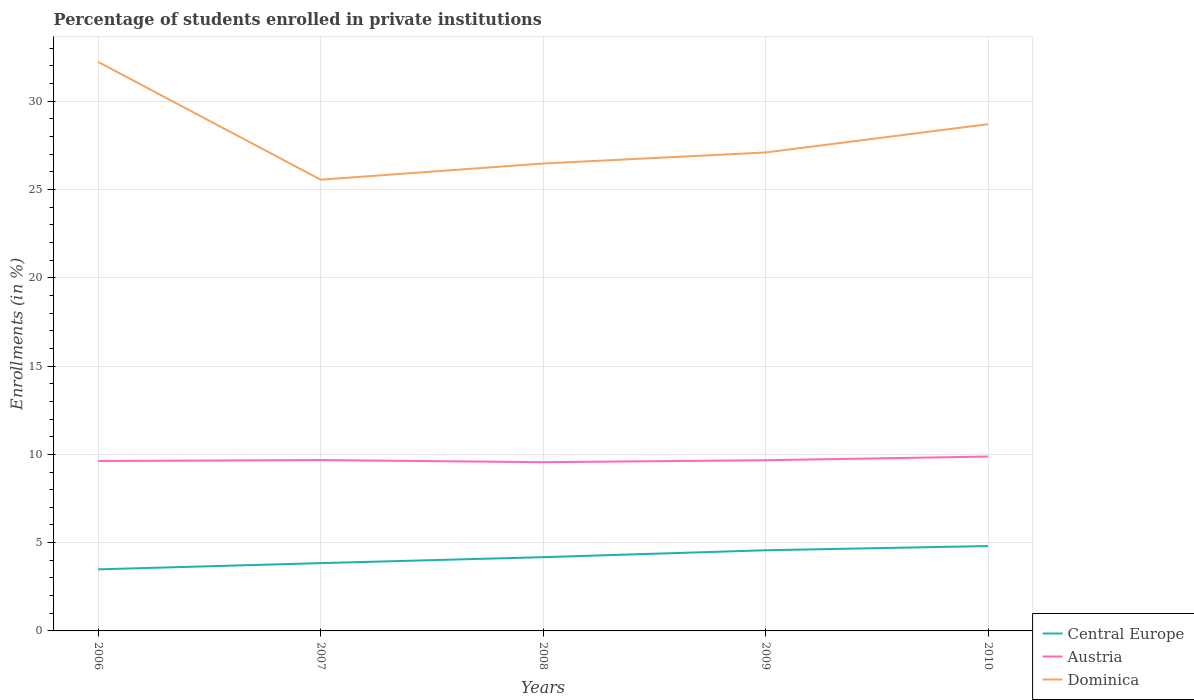How many different coloured lines are there?
Your response must be concise. 3. Across all years, what is the maximum percentage of trained teachers in Austria?
Ensure brevity in your answer.  9.56. What is the total percentage of trained teachers in Austria in the graph?
Your answer should be very brief. 0.07. What is the difference between the highest and the second highest percentage of trained teachers in Central Europe?
Your response must be concise. 1.32. What is the difference between the highest and the lowest percentage of trained teachers in Central Europe?
Your response must be concise. 3. How many lines are there?
Your answer should be very brief. 3. How many years are there in the graph?
Provide a succinct answer. 5. What is the difference between two consecutive major ticks on the Y-axis?
Offer a very short reply. 5. Are the values on the major ticks of Y-axis written in scientific E-notation?
Your answer should be compact. No. Does the graph contain any zero values?
Offer a very short reply. No. Does the graph contain grids?
Your answer should be compact. Yes. Where does the legend appear in the graph?
Provide a short and direct response. Bottom right. How many legend labels are there?
Ensure brevity in your answer.  3. How are the legend labels stacked?
Give a very brief answer. Vertical. What is the title of the graph?
Give a very brief answer. Percentage of students enrolled in private institutions. Does "Philippines" appear as one of the legend labels in the graph?
Keep it short and to the point. No. What is the label or title of the Y-axis?
Provide a short and direct response. Enrollments (in %). What is the Enrollments (in %) in Central Europe in 2006?
Offer a terse response. 3.49. What is the Enrollments (in %) of Austria in 2006?
Ensure brevity in your answer.  9.62. What is the Enrollments (in %) in Dominica in 2006?
Offer a terse response. 32.23. What is the Enrollments (in %) in Central Europe in 2007?
Give a very brief answer. 3.84. What is the Enrollments (in %) of Austria in 2007?
Offer a terse response. 9.68. What is the Enrollments (in %) in Dominica in 2007?
Offer a terse response. 25.56. What is the Enrollments (in %) in Central Europe in 2008?
Ensure brevity in your answer.  4.18. What is the Enrollments (in %) in Austria in 2008?
Your answer should be very brief. 9.56. What is the Enrollments (in %) in Dominica in 2008?
Offer a terse response. 26.47. What is the Enrollments (in %) in Central Europe in 2009?
Give a very brief answer. 4.57. What is the Enrollments (in %) of Austria in 2009?
Offer a terse response. 9.67. What is the Enrollments (in %) in Dominica in 2009?
Provide a short and direct response. 27.1. What is the Enrollments (in %) in Central Europe in 2010?
Your answer should be compact. 4.81. What is the Enrollments (in %) in Austria in 2010?
Your answer should be compact. 9.88. What is the Enrollments (in %) in Dominica in 2010?
Your answer should be very brief. 28.7. Across all years, what is the maximum Enrollments (in %) in Central Europe?
Provide a succinct answer. 4.81. Across all years, what is the maximum Enrollments (in %) in Austria?
Offer a terse response. 9.88. Across all years, what is the maximum Enrollments (in %) of Dominica?
Make the answer very short. 32.23. Across all years, what is the minimum Enrollments (in %) of Central Europe?
Offer a very short reply. 3.49. Across all years, what is the minimum Enrollments (in %) of Austria?
Your response must be concise. 9.56. Across all years, what is the minimum Enrollments (in %) in Dominica?
Your answer should be compact. 25.56. What is the total Enrollments (in %) in Central Europe in the graph?
Keep it short and to the point. 20.88. What is the total Enrollments (in %) in Austria in the graph?
Your answer should be very brief. 48.41. What is the total Enrollments (in %) of Dominica in the graph?
Offer a very short reply. 140.06. What is the difference between the Enrollments (in %) in Central Europe in 2006 and that in 2007?
Offer a terse response. -0.35. What is the difference between the Enrollments (in %) in Austria in 2006 and that in 2007?
Your answer should be very brief. -0.05. What is the difference between the Enrollments (in %) in Dominica in 2006 and that in 2007?
Provide a short and direct response. 6.67. What is the difference between the Enrollments (in %) in Central Europe in 2006 and that in 2008?
Ensure brevity in your answer.  -0.69. What is the difference between the Enrollments (in %) of Austria in 2006 and that in 2008?
Your response must be concise. 0.07. What is the difference between the Enrollments (in %) of Dominica in 2006 and that in 2008?
Your response must be concise. 5.75. What is the difference between the Enrollments (in %) of Central Europe in 2006 and that in 2009?
Provide a short and direct response. -1.08. What is the difference between the Enrollments (in %) of Austria in 2006 and that in 2009?
Your answer should be very brief. -0.04. What is the difference between the Enrollments (in %) of Dominica in 2006 and that in 2009?
Offer a terse response. 5.13. What is the difference between the Enrollments (in %) in Central Europe in 2006 and that in 2010?
Offer a very short reply. -1.32. What is the difference between the Enrollments (in %) of Austria in 2006 and that in 2010?
Give a very brief answer. -0.25. What is the difference between the Enrollments (in %) of Dominica in 2006 and that in 2010?
Your response must be concise. 3.53. What is the difference between the Enrollments (in %) of Central Europe in 2007 and that in 2008?
Provide a succinct answer. -0.34. What is the difference between the Enrollments (in %) of Austria in 2007 and that in 2008?
Provide a succinct answer. 0.12. What is the difference between the Enrollments (in %) in Dominica in 2007 and that in 2008?
Your answer should be very brief. -0.92. What is the difference between the Enrollments (in %) in Central Europe in 2007 and that in 2009?
Offer a very short reply. -0.73. What is the difference between the Enrollments (in %) in Austria in 2007 and that in 2009?
Offer a terse response. 0.01. What is the difference between the Enrollments (in %) of Dominica in 2007 and that in 2009?
Your answer should be compact. -1.54. What is the difference between the Enrollments (in %) of Central Europe in 2007 and that in 2010?
Offer a terse response. -0.97. What is the difference between the Enrollments (in %) in Austria in 2007 and that in 2010?
Keep it short and to the point. -0.2. What is the difference between the Enrollments (in %) of Dominica in 2007 and that in 2010?
Ensure brevity in your answer.  -3.14. What is the difference between the Enrollments (in %) of Central Europe in 2008 and that in 2009?
Ensure brevity in your answer.  -0.39. What is the difference between the Enrollments (in %) of Austria in 2008 and that in 2009?
Your answer should be very brief. -0.11. What is the difference between the Enrollments (in %) of Dominica in 2008 and that in 2009?
Keep it short and to the point. -0.63. What is the difference between the Enrollments (in %) in Central Europe in 2008 and that in 2010?
Offer a terse response. -0.63. What is the difference between the Enrollments (in %) of Austria in 2008 and that in 2010?
Provide a short and direct response. -0.32. What is the difference between the Enrollments (in %) of Dominica in 2008 and that in 2010?
Your answer should be very brief. -2.23. What is the difference between the Enrollments (in %) in Central Europe in 2009 and that in 2010?
Give a very brief answer. -0.24. What is the difference between the Enrollments (in %) of Austria in 2009 and that in 2010?
Keep it short and to the point. -0.21. What is the difference between the Enrollments (in %) in Dominica in 2009 and that in 2010?
Give a very brief answer. -1.6. What is the difference between the Enrollments (in %) in Central Europe in 2006 and the Enrollments (in %) in Austria in 2007?
Your answer should be very brief. -6.19. What is the difference between the Enrollments (in %) in Central Europe in 2006 and the Enrollments (in %) in Dominica in 2007?
Provide a succinct answer. -22.07. What is the difference between the Enrollments (in %) in Austria in 2006 and the Enrollments (in %) in Dominica in 2007?
Provide a short and direct response. -15.93. What is the difference between the Enrollments (in %) in Central Europe in 2006 and the Enrollments (in %) in Austria in 2008?
Provide a short and direct response. -6.07. What is the difference between the Enrollments (in %) of Central Europe in 2006 and the Enrollments (in %) of Dominica in 2008?
Keep it short and to the point. -22.99. What is the difference between the Enrollments (in %) of Austria in 2006 and the Enrollments (in %) of Dominica in 2008?
Your response must be concise. -16.85. What is the difference between the Enrollments (in %) of Central Europe in 2006 and the Enrollments (in %) of Austria in 2009?
Your answer should be very brief. -6.18. What is the difference between the Enrollments (in %) of Central Europe in 2006 and the Enrollments (in %) of Dominica in 2009?
Keep it short and to the point. -23.61. What is the difference between the Enrollments (in %) of Austria in 2006 and the Enrollments (in %) of Dominica in 2009?
Provide a succinct answer. -17.48. What is the difference between the Enrollments (in %) of Central Europe in 2006 and the Enrollments (in %) of Austria in 2010?
Your answer should be compact. -6.39. What is the difference between the Enrollments (in %) of Central Europe in 2006 and the Enrollments (in %) of Dominica in 2010?
Your answer should be very brief. -25.21. What is the difference between the Enrollments (in %) of Austria in 2006 and the Enrollments (in %) of Dominica in 2010?
Provide a succinct answer. -19.08. What is the difference between the Enrollments (in %) of Central Europe in 2007 and the Enrollments (in %) of Austria in 2008?
Make the answer very short. -5.72. What is the difference between the Enrollments (in %) in Central Europe in 2007 and the Enrollments (in %) in Dominica in 2008?
Your answer should be very brief. -22.63. What is the difference between the Enrollments (in %) in Austria in 2007 and the Enrollments (in %) in Dominica in 2008?
Keep it short and to the point. -16.8. What is the difference between the Enrollments (in %) of Central Europe in 2007 and the Enrollments (in %) of Austria in 2009?
Your response must be concise. -5.83. What is the difference between the Enrollments (in %) of Central Europe in 2007 and the Enrollments (in %) of Dominica in 2009?
Provide a succinct answer. -23.26. What is the difference between the Enrollments (in %) in Austria in 2007 and the Enrollments (in %) in Dominica in 2009?
Your response must be concise. -17.42. What is the difference between the Enrollments (in %) of Central Europe in 2007 and the Enrollments (in %) of Austria in 2010?
Offer a terse response. -6.04. What is the difference between the Enrollments (in %) of Central Europe in 2007 and the Enrollments (in %) of Dominica in 2010?
Offer a terse response. -24.86. What is the difference between the Enrollments (in %) of Austria in 2007 and the Enrollments (in %) of Dominica in 2010?
Your response must be concise. -19.02. What is the difference between the Enrollments (in %) in Central Europe in 2008 and the Enrollments (in %) in Austria in 2009?
Keep it short and to the point. -5.49. What is the difference between the Enrollments (in %) of Central Europe in 2008 and the Enrollments (in %) of Dominica in 2009?
Provide a short and direct response. -22.92. What is the difference between the Enrollments (in %) in Austria in 2008 and the Enrollments (in %) in Dominica in 2009?
Offer a terse response. -17.54. What is the difference between the Enrollments (in %) in Central Europe in 2008 and the Enrollments (in %) in Austria in 2010?
Ensure brevity in your answer.  -5.7. What is the difference between the Enrollments (in %) of Central Europe in 2008 and the Enrollments (in %) of Dominica in 2010?
Ensure brevity in your answer.  -24.52. What is the difference between the Enrollments (in %) of Austria in 2008 and the Enrollments (in %) of Dominica in 2010?
Ensure brevity in your answer.  -19.15. What is the difference between the Enrollments (in %) in Central Europe in 2009 and the Enrollments (in %) in Austria in 2010?
Provide a short and direct response. -5.31. What is the difference between the Enrollments (in %) in Central Europe in 2009 and the Enrollments (in %) in Dominica in 2010?
Your response must be concise. -24.13. What is the difference between the Enrollments (in %) of Austria in 2009 and the Enrollments (in %) of Dominica in 2010?
Offer a very short reply. -19.03. What is the average Enrollments (in %) in Central Europe per year?
Give a very brief answer. 4.18. What is the average Enrollments (in %) in Austria per year?
Provide a succinct answer. 9.68. What is the average Enrollments (in %) of Dominica per year?
Keep it short and to the point. 28.01. In the year 2006, what is the difference between the Enrollments (in %) of Central Europe and Enrollments (in %) of Austria?
Provide a succinct answer. -6.14. In the year 2006, what is the difference between the Enrollments (in %) of Central Europe and Enrollments (in %) of Dominica?
Your answer should be compact. -28.74. In the year 2006, what is the difference between the Enrollments (in %) of Austria and Enrollments (in %) of Dominica?
Keep it short and to the point. -22.6. In the year 2007, what is the difference between the Enrollments (in %) of Central Europe and Enrollments (in %) of Austria?
Your answer should be very brief. -5.84. In the year 2007, what is the difference between the Enrollments (in %) in Central Europe and Enrollments (in %) in Dominica?
Your answer should be very brief. -21.72. In the year 2007, what is the difference between the Enrollments (in %) in Austria and Enrollments (in %) in Dominica?
Your response must be concise. -15.88. In the year 2008, what is the difference between the Enrollments (in %) of Central Europe and Enrollments (in %) of Austria?
Offer a very short reply. -5.38. In the year 2008, what is the difference between the Enrollments (in %) in Central Europe and Enrollments (in %) in Dominica?
Your answer should be very brief. -22.3. In the year 2008, what is the difference between the Enrollments (in %) in Austria and Enrollments (in %) in Dominica?
Your answer should be very brief. -16.92. In the year 2009, what is the difference between the Enrollments (in %) of Central Europe and Enrollments (in %) of Austria?
Ensure brevity in your answer.  -5.1. In the year 2009, what is the difference between the Enrollments (in %) in Central Europe and Enrollments (in %) in Dominica?
Your answer should be very brief. -22.53. In the year 2009, what is the difference between the Enrollments (in %) in Austria and Enrollments (in %) in Dominica?
Make the answer very short. -17.43. In the year 2010, what is the difference between the Enrollments (in %) in Central Europe and Enrollments (in %) in Austria?
Your answer should be very brief. -5.07. In the year 2010, what is the difference between the Enrollments (in %) of Central Europe and Enrollments (in %) of Dominica?
Offer a terse response. -23.9. In the year 2010, what is the difference between the Enrollments (in %) of Austria and Enrollments (in %) of Dominica?
Offer a very short reply. -18.83. What is the ratio of the Enrollments (in %) in Central Europe in 2006 to that in 2007?
Ensure brevity in your answer.  0.91. What is the ratio of the Enrollments (in %) in Austria in 2006 to that in 2007?
Make the answer very short. 0.99. What is the ratio of the Enrollments (in %) of Dominica in 2006 to that in 2007?
Keep it short and to the point. 1.26. What is the ratio of the Enrollments (in %) of Central Europe in 2006 to that in 2008?
Offer a very short reply. 0.83. What is the ratio of the Enrollments (in %) in Austria in 2006 to that in 2008?
Your response must be concise. 1.01. What is the ratio of the Enrollments (in %) of Dominica in 2006 to that in 2008?
Offer a terse response. 1.22. What is the ratio of the Enrollments (in %) of Central Europe in 2006 to that in 2009?
Ensure brevity in your answer.  0.76. What is the ratio of the Enrollments (in %) of Austria in 2006 to that in 2009?
Offer a terse response. 1. What is the ratio of the Enrollments (in %) in Dominica in 2006 to that in 2009?
Offer a terse response. 1.19. What is the ratio of the Enrollments (in %) of Central Europe in 2006 to that in 2010?
Provide a short and direct response. 0.73. What is the ratio of the Enrollments (in %) of Austria in 2006 to that in 2010?
Keep it short and to the point. 0.97. What is the ratio of the Enrollments (in %) in Dominica in 2006 to that in 2010?
Your answer should be very brief. 1.12. What is the ratio of the Enrollments (in %) in Central Europe in 2007 to that in 2008?
Your answer should be very brief. 0.92. What is the ratio of the Enrollments (in %) of Austria in 2007 to that in 2008?
Provide a short and direct response. 1.01. What is the ratio of the Enrollments (in %) in Dominica in 2007 to that in 2008?
Keep it short and to the point. 0.97. What is the ratio of the Enrollments (in %) of Central Europe in 2007 to that in 2009?
Give a very brief answer. 0.84. What is the ratio of the Enrollments (in %) in Austria in 2007 to that in 2009?
Give a very brief answer. 1. What is the ratio of the Enrollments (in %) of Dominica in 2007 to that in 2009?
Your answer should be very brief. 0.94. What is the ratio of the Enrollments (in %) in Central Europe in 2007 to that in 2010?
Provide a succinct answer. 0.8. What is the ratio of the Enrollments (in %) in Austria in 2007 to that in 2010?
Offer a terse response. 0.98. What is the ratio of the Enrollments (in %) of Dominica in 2007 to that in 2010?
Ensure brevity in your answer.  0.89. What is the ratio of the Enrollments (in %) in Central Europe in 2008 to that in 2009?
Make the answer very short. 0.91. What is the ratio of the Enrollments (in %) of Austria in 2008 to that in 2009?
Give a very brief answer. 0.99. What is the ratio of the Enrollments (in %) in Dominica in 2008 to that in 2009?
Offer a terse response. 0.98. What is the ratio of the Enrollments (in %) in Central Europe in 2008 to that in 2010?
Give a very brief answer. 0.87. What is the ratio of the Enrollments (in %) of Austria in 2008 to that in 2010?
Your answer should be very brief. 0.97. What is the ratio of the Enrollments (in %) of Dominica in 2008 to that in 2010?
Give a very brief answer. 0.92. What is the ratio of the Enrollments (in %) of Central Europe in 2009 to that in 2010?
Give a very brief answer. 0.95. What is the ratio of the Enrollments (in %) of Austria in 2009 to that in 2010?
Keep it short and to the point. 0.98. What is the ratio of the Enrollments (in %) of Dominica in 2009 to that in 2010?
Offer a very short reply. 0.94. What is the difference between the highest and the second highest Enrollments (in %) in Central Europe?
Give a very brief answer. 0.24. What is the difference between the highest and the second highest Enrollments (in %) in Austria?
Make the answer very short. 0.2. What is the difference between the highest and the second highest Enrollments (in %) in Dominica?
Offer a terse response. 3.53. What is the difference between the highest and the lowest Enrollments (in %) of Central Europe?
Provide a short and direct response. 1.32. What is the difference between the highest and the lowest Enrollments (in %) of Austria?
Your answer should be very brief. 0.32. What is the difference between the highest and the lowest Enrollments (in %) of Dominica?
Offer a terse response. 6.67. 